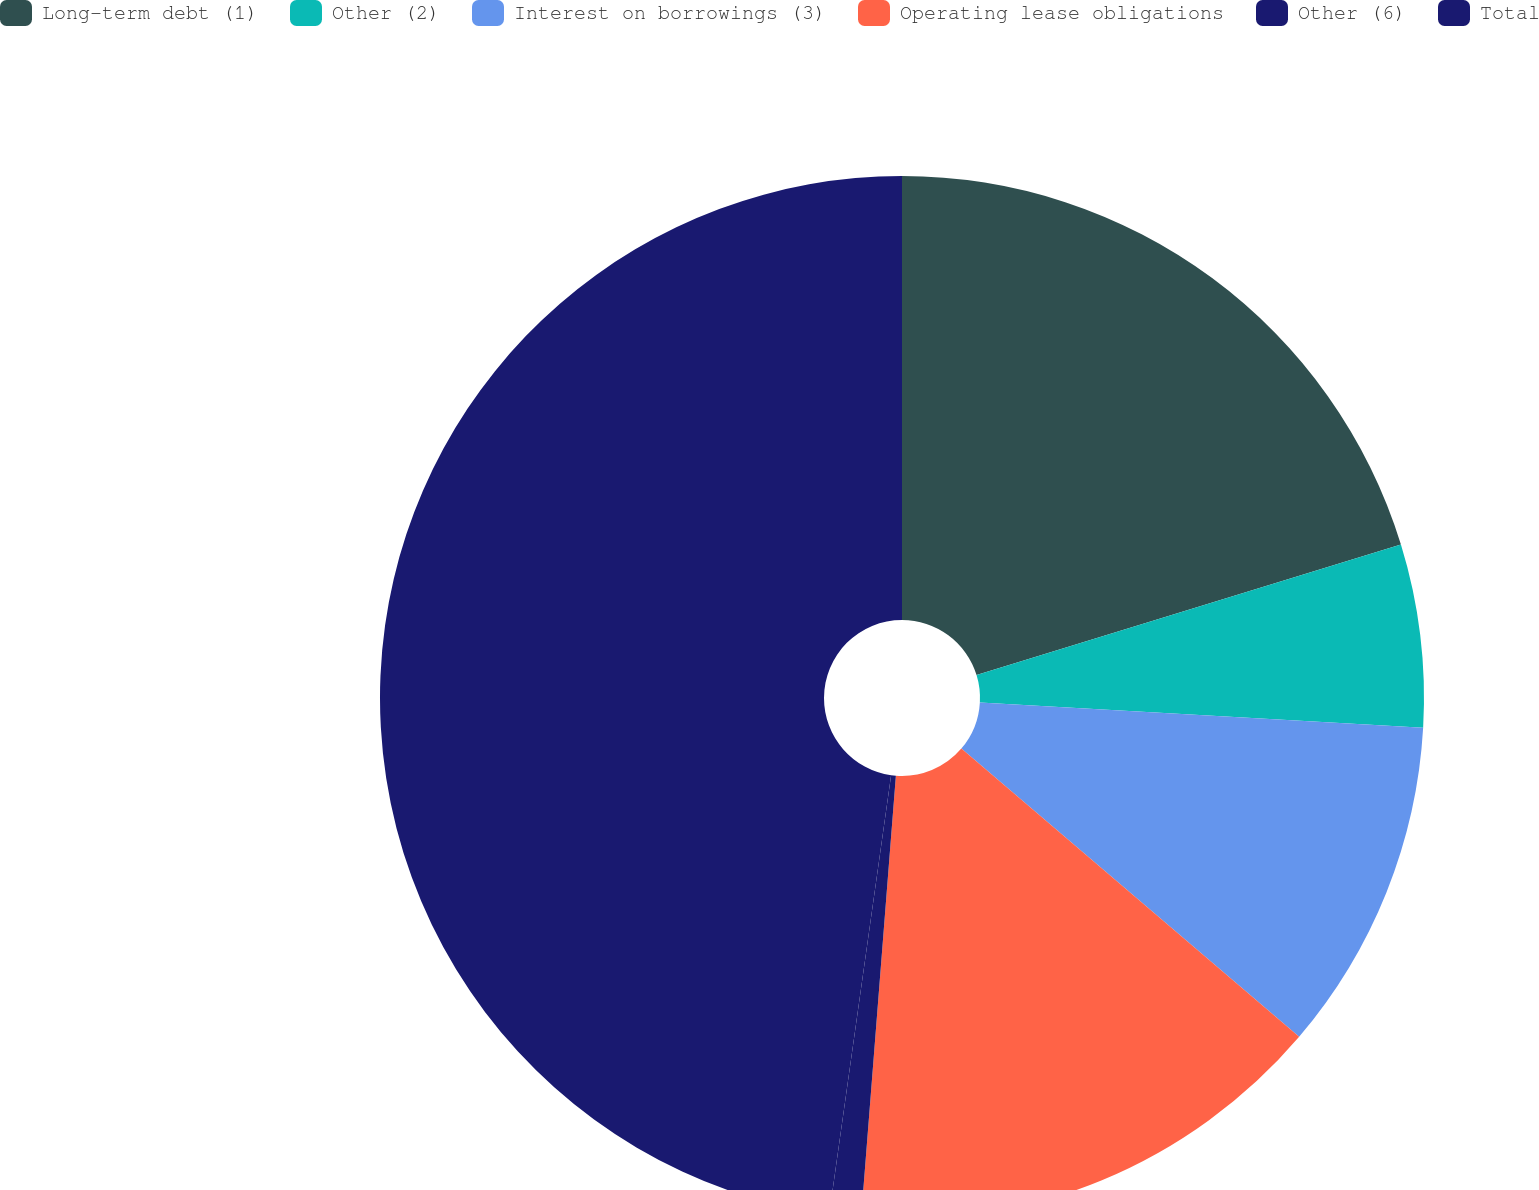Convert chart to OTSL. <chart><loc_0><loc_0><loc_500><loc_500><pie_chart><fcel>Long-term debt (1)<fcel>Other (2)<fcel>Interest on borrowings (3)<fcel>Operating lease obligations<fcel>Other (6)<fcel>Total<nl><fcel>20.25%<fcel>5.66%<fcel>10.33%<fcel>15.01%<fcel>0.98%<fcel>47.77%<nl></chart> 